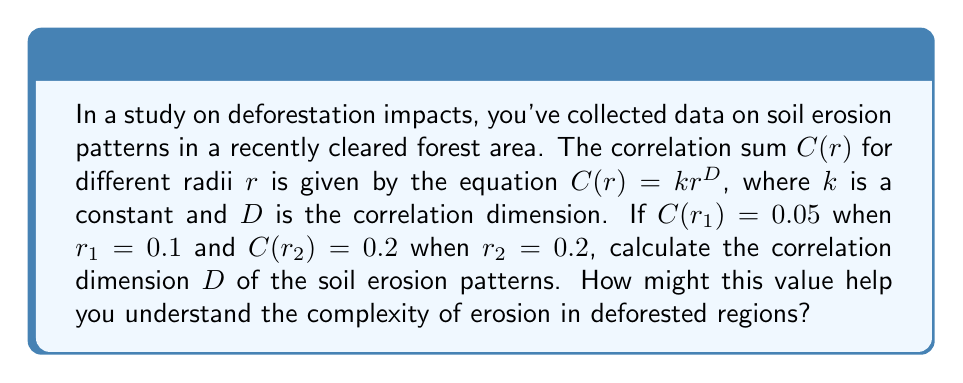Help me with this question. To solve this problem, we'll use the given equation and the two data points to calculate the correlation dimension $D$. Here's a step-by-step approach:

1) We have the equation $C(r) = kr^D$

2) For the first data point: $0.05 = k(0.1)^D$
   For the second data point: $0.2 = k(0.2)^D$

3) Divide the second equation by the first:

   $$\frac{0.2}{0.05} = \frac{k(0.2)^D}{k(0.1)^D}$$

4) The $k$ cancels out:

   $$4 = \left(\frac{0.2}{0.1}\right)^D = 2^D$$

5) Take the logarithm of both sides:

   $$\log 4 = D \log 2$$

6) Solve for $D$:

   $$D = \frac{\log 4}{\log 2} = \frac{\log 2^2}{\log 2} = 2$$

The correlation dimension $D = 2$ suggests that the soil erosion patterns have a complexity similar to that of a two-dimensional surface. This indicates that the erosion patterns are more complex than a simple linear pattern (which would have $D \approx 1$) but less complex than a highly turbulent, volume-filling pattern (which would have $D$ closer to 3).

For a curious student studying deforestation impacts, this value helps understand that soil erosion in the deforested area is not a simple, predictable process. It suggests that multiple factors are influencing the erosion patterns, potentially including slope, soil type, rainfall patterns, and remaining vegetation. This complexity highlights the intricate environmental changes that occur following deforestation and underscores the importance of considering multiple factors when assessing and mitigating the impacts on local communities.
Answer: $D = 2$ 